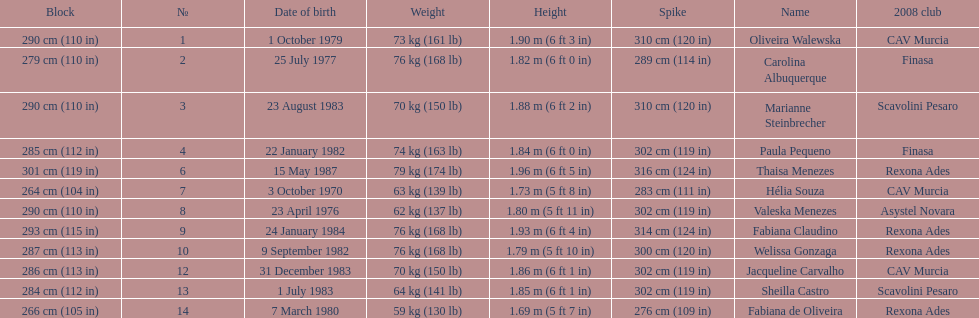Oliveira walewska has the same block as how many other players? 2. 